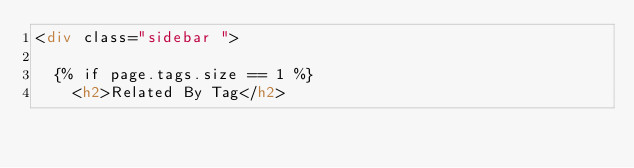<code> <loc_0><loc_0><loc_500><loc_500><_HTML_><div class="sidebar ">

  {% if page.tags.size == 1 %}
    <h2>Related By Tag</h2></code> 